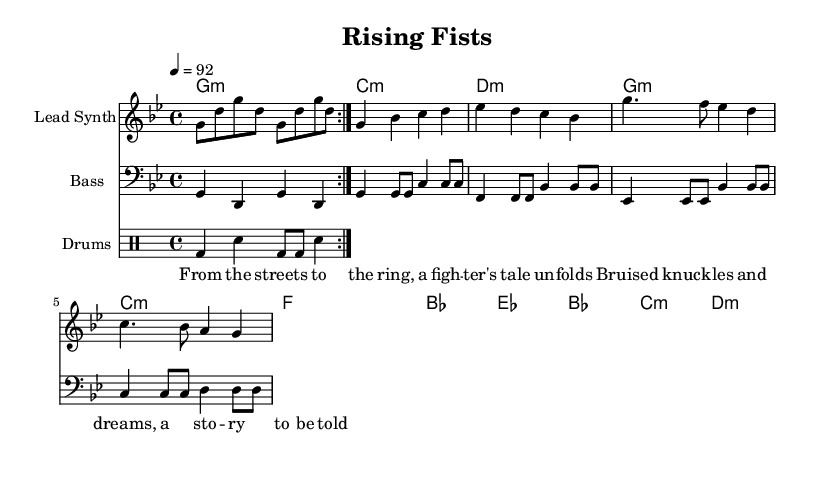What is the key signature of this music? The key signature is G minor, which includes two flats (B flat and E flat). This is indicated at the beginning of the sheet music in the key signature section.
Answer: G minor What is the time signature of the piece? The time signature is 4/4, which means there are four beats in each measure and a quarter note receives one beat. This can be seen in the time signature notation at the beginning of the sheet music.
Answer: 4/4 What is the tempo marking of the music? The tempo marking indicates the piece should be played at 92 beats per minute. This is explicitly stated after the time signature at the beginning of the score.
Answer: 92 How many measures are in the introduction? The introduction contains four measures, as can be counted from the repeated section in the melody line that explicitly shows the rhythm without any lyrics or chords.
Answer: Four What is the primary theme reflected in the lyrics? The primary theme reflected in the lyrics speaks about a fighter's journey from challenging beginnings to success in the ring, emphasizing resilience and ambition. This is evident in the lyrics provided which highlight struggle and determination.
Answer: Fighter's journey What instruments are featured in this piece? The sheet music features a lead synth, bass, and drums. These instruments are indicated by their respective staff labels at the beginning of each line within the score.
Answer: Lead synth, bass, drums What musical genre does this piece belong to? This piece belongs to the rap genre, specifically focused on hip-hop themes highlighting inspiring stories of underdog fighters. This is indicated by its lyrical content and rhythmic structure typical of rap music.
Answer: Rap 